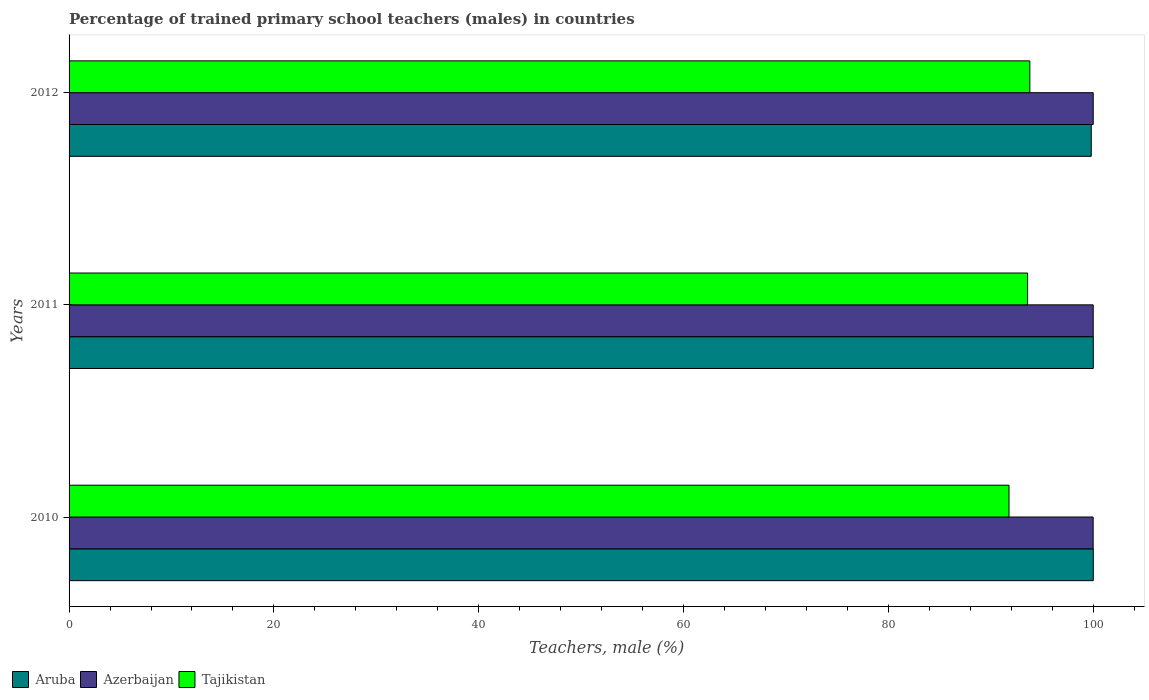How many different coloured bars are there?
Keep it short and to the point. 3. How many groups of bars are there?
Provide a succinct answer. 3. How many bars are there on the 1st tick from the top?
Ensure brevity in your answer.  3. How many bars are there on the 1st tick from the bottom?
Your answer should be very brief. 3. What is the label of the 3rd group of bars from the top?
Offer a terse response. 2010. In how many cases, is the number of bars for a given year not equal to the number of legend labels?
Provide a short and direct response. 0. Across all years, what is the maximum percentage of trained primary school teachers (males) in Tajikistan?
Provide a short and direct response. 93.8. Across all years, what is the minimum percentage of trained primary school teachers (males) in Tajikistan?
Offer a very short reply. 91.77. In which year was the percentage of trained primary school teachers (males) in Aruba minimum?
Keep it short and to the point. 2012. What is the total percentage of trained primary school teachers (males) in Tajikistan in the graph?
Give a very brief answer. 279.16. What is the difference between the percentage of trained primary school teachers (males) in Aruba in 2011 and that in 2012?
Give a very brief answer. 0.2. What is the difference between the percentage of trained primary school teachers (males) in Aruba in 2011 and the percentage of trained primary school teachers (males) in Azerbaijan in 2012?
Offer a terse response. 0.01. What is the average percentage of trained primary school teachers (males) in Tajikistan per year?
Your answer should be compact. 93.05. In the year 2010, what is the difference between the percentage of trained primary school teachers (males) in Tajikistan and percentage of trained primary school teachers (males) in Azerbaijan?
Offer a very short reply. -8.22. What is the ratio of the percentage of trained primary school teachers (males) in Tajikistan in 2010 to that in 2011?
Keep it short and to the point. 0.98. Is the percentage of trained primary school teachers (males) in Azerbaijan in 2010 less than that in 2011?
Your response must be concise. Yes. Is the difference between the percentage of trained primary school teachers (males) in Tajikistan in 2010 and 2012 greater than the difference between the percentage of trained primary school teachers (males) in Azerbaijan in 2010 and 2012?
Provide a short and direct response. No. What is the difference between the highest and the second highest percentage of trained primary school teachers (males) in Azerbaijan?
Ensure brevity in your answer.  0. What is the difference between the highest and the lowest percentage of trained primary school teachers (males) in Tajikistan?
Your answer should be compact. 2.03. In how many years, is the percentage of trained primary school teachers (males) in Aruba greater than the average percentage of trained primary school teachers (males) in Aruba taken over all years?
Your response must be concise. 2. Is the sum of the percentage of trained primary school teachers (males) in Aruba in 2010 and 2011 greater than the maximum percentage of trained primary school teachers (males) in Tajikistan across all years?
Offer a terse response. Yes. What does the 3rd bar from the top in 2012 represents?
Your response must be concise. Aruba. What does the 1st bar from the bottom in 2011 represents?
Provide a succinct answer. Aruba. How many bars are there?
Keep it short and to the point. 9. Are all the bars in the graph horizontal?
Offer a very short reply. Yes. What is the difference between two consecutive major ticks on the X-axis?
Keep it short and to the point. 20. What is the title of the graph?
Your answer should be very brief. Percentage of trained primary school teachers (males) in countries. Does "Latin America(all income levels)" appear as one of the legend labels in the graph?
Keep it short and to the point. No. What is the label or title of the X-axis?
Your answer should be very brief. Teachers, male (%). What is the label or title of the Y-axis?
Your response must be concise. Years. What is the Teachers, male (%) of Aruba in 2010?
Your answer should be compact. 100. What is the Teachers, male (%) of Azerbaijan in 2010?
Provide a short and direct response. 99.99. What is the Teachers, male (%) of Tajikistan in 2010?
Your answer should be very brief. 91.77. What is the Teachers, male (%) in Azerbaijan in 2011?
Make the answer very short. 99.99. What is the Teachers, male (%) in Tajikistan in 2011?
Ensure brevity in your answer.  93.59. What is the Teachers, male (%) of Aruba in 2012?
Make the answer very short. 99.8. What is the Teachers, male (%) in Azerbaijan in 2012?
Make the answer very short. 99.99. What is the Teachers, male (%) in Tajikistan in 2012?
Give a very brief answer. 93.8. Across all years, what is the maximum Teachers, male (%) of Aruba?
Keep it short and to the point. 100. Across all years, what is the maximum Teachers, male (%) in Azerbaijan?
Your answer should be very brief. 99.99. Across all years, what is the maximum Teachers, male (%) in Tajikistan?
Keep it short and to the point. 93.8. Across all years, what is the minimum Teachers, male (%) in Aruba?
Ensure brevity in your answer.  99.8. Across all years, what is the minimum Teachers, male (%) in Azerbaijan?
Provide a succinct answer. 99.99. Across all years, what is the minimum Teachers, male (%) in Tajikistan?
Your answer should be very brief. 91.77. What is the total Teachers, male (%) in Aruba in the graph?
Provide a succinct answer. 299.8. What is the total Teachers, male (%) of Azerbaijan in the graph?
Make the answer very short. 299.97. What is the total Teachers, male (%) in Tajikistan in the graph?
Provide a short and direct response. 279.16. What is the difference between the Teachers, male (%) in Aruba in 2010 and that in 2011?
Offer a terse response. 0. What is the difference between the Teachers, male (%) in Azerbaijan in 2010 and that in 2011?
Your answer should be very brief. -0.01. What is the difference between the Teachers, male (%) in Tajikistan in 2010 and that in 2011?
Offer a terse response. -1.81. What is the difference between the Teachers, male (%) of Aruba in 2010 and that in 2012?
Offer a very short reply. 0.2. What is the difference between the Teachers, male (%) of Azerbaijan in 2010 and that in 2012?
Your answer should be compact. -0.01. What is the difference between the Teachers, male (%) of Tajikistan in 2010 and that in 2012?
Offer a terse response. -2.03. What is the difference between the Teachers, male (%) in Aruba in 2011 and that in 2012?
Your answer should be compact. 0.2. What is the difference between the Teachers, male (%) in Azerbaijan in 2011 and that in 2012?
Offer a very short reply. -0. What is the difference between the Teachers, male (%) of Tajikistan in 2011 and that in 2012?
Your response must be concise. -0.22. What is the difference between the Teachers, male (%) of Aruba in 2010 and the Teachers, male (%) of Azerbaijan in 2011?
Provide a short and direct response. 0.01. What is the difference between the Teachers, male (%) of Aruba in 2010 and the Teachers, male (%) of Tajikistan in 2011?
Keep it short and to the point. 6.41. What is the difference between the Teachers, male (%) of Azerbaijan in 2010 and the Teachers, male (%) of Tajikistan in 2011?
Give a very brief answer. 6.4. What is the difference between the Teachers, male (%) of Aruba in 2010 and the Teachers, male (%) of Azerbaijan in 2012?
Your response must be concise. 0.01. What is the difference between the Teachers, male (%) in Aruba in 2010 and the Teachers, male (%) in Tajikistan in 2012?
Keep it short and to the point. 6.2. What is the difference between the Teachers, male (%) in Azerbaijan in 2010 and the Teachers, male (%) in Tajikistan in 2012?
Your answer should be very brief. 6.18. What is the difference between the Teachers, male (%) in Aruba in 2011 and the Teachers, male (%) in Azerbaijan in 2012?
Offer a very short reply. 0.01. What is the difference between the Teachers, male (%) of Aruba in 2011 and the Teachers, male (%) of Tajikistan in 2012?
Your response must be concise. 6.2. What is the difference between the Teachers, male (%) in Azerbaijan in 2011 and the Teachers, male (%) in Tajikistan in 2012?
Your response must be concise. 6.19. What is the average Teachers, male (%) in Aruba per year?
Your answer should be compact. 99.93. What is the average Teachers, male (%) in Azerbaijan per year?
Ensure brevity in your answer.  99.99. What is the average Teachers, male (%) in Tajikistan per year?
Provide a succinct answer. 93.05. In the year 2010, what is the difference between the Teachers, male (%) in Aruba and Teachers, male (%) in Azerbaijan?
Keep it short and to the point. 0.01. In the year 2010, what is the difference between the Teachers, male (%) of Aruba and Teachers, male (%) of Tajikistan?
Your answer should be very brief. 8.23. In the year 2010, what is the difference between the Teachers, male (%) in Azerbaijan and Teachers, male (%) in Tajikistan?
Offer a terse response. 8.22. In the year 2011, what is the difference between the Teachers, male (%) of Aruba and Teachers, male (%) of Azerbaijan?
Provide a succinct answer. 0.01. In the year 2011, what is the difference between the Teachers, male (%) in Aruba and Teachers, male (%) in Tajikistan?
Provide a succinct answer. 6.41. In the year 2011, what is the difference between the Teachers, male (%) in Azerbaijan and Teachers, male (%) in Tajikistan?
Ensure brevity in your answer.  6.41. In the year 2012, what is the difference between the Teachers, male (%) of Aruba and Teachers, male (%) of Azerbaijan?
Offer a terse response. -0.19. In the year 2012, what is the difference between the Teachers, male (%) of Aruba and Teachers, male (%) of Tajikistan?
Provide a succinct answer. 6. In the year 2012, what is the difference between the Teachers, male (%) of Azerbaijan and Teachers, male (%) of Tajikistan?
Your answer should be very brief. 6.19. What is the ratio of the Teachers, male (%) of Aruba in 2010 to that in 2011?
Your answer should be very brief. 1. What is the ratio of the Teachers, male (%) of Azerbaijan in 2010 to that in 2011?
Offer a terse response. 1. What is the ratio of the Teachers, male (%) of Tajikistan in 2010 to that in 2011?
Provide a succinct answer. 0.98. What is the ratio of the Teachers, male (%) of Aruba in 2010 to that in 2012?
Your response must be concise. 1. What is the ratio of the Teachers, male (%) in Azerbaijan in 2010 to that in 2012?
Ensure brevity in your answer.  1. What is the ratio of the Teachers, male (%) in Tajikistan in 2010 to that in 2012?
Give a very brief answer. 0.98. What is the ratio of the Teachers, male (%) in Azerbaijan in 2011 to that in 2012?
Your answer should be compact. 1. What is the ratio of the Teachers, male (%) of Tajikistan in 2011 to that in 2012?
Give a very brief answer. 1. What is the difference between the highest and the second highest Teachers, male (%) in Aruba?
Your response must be concise. 0. What is the difference between the highest and the second highest Teachers, male (%) of Azerbaijan?
Your answer should be very brief. 0. What is the difference between the highest and the second highest Teachers, male (%) in Tajikistan?
Your answer should be compact. 0.22. What is the difference between the highest and the lowest Teachers, male (%) in Aruba?
Your answer should be compact. 0.2. What is the difference between the highest and the lowest Teachers, male (%) in Azerbaijan?
Ensure brevity in your answer.  0.01. What is the difference between the highest and the lowest Teachers, male (%) in Tajikistan?
Offer a terse response. 2.03. 